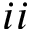Convert formula to latex. <formula><loc_0><loc_0><loc_500><loc_500>i i</formula> 